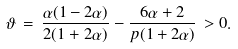Convert formula to latex. <formula><loc_0><loc_0><loc_500><loc_500>\vartheta \, = \, \frac { \alpha ( 1 - 2 \alpha ) } { 2 ( 1 + 2 \alpha ) } - \frac { 6 \alpha + 2 } { p ( 1 + 2 \alpha ) } \, > 0 .</formula> 